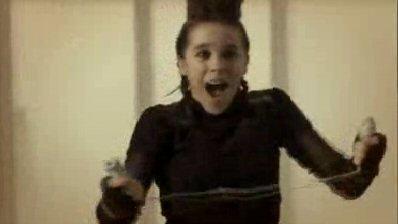How many people are in the photo?
Give a very brief answer. 1. How many of the girls hands are visible?
Give a very brief answer. 2. How many wheels does the truck have?
Give a very brief answer. 0. 